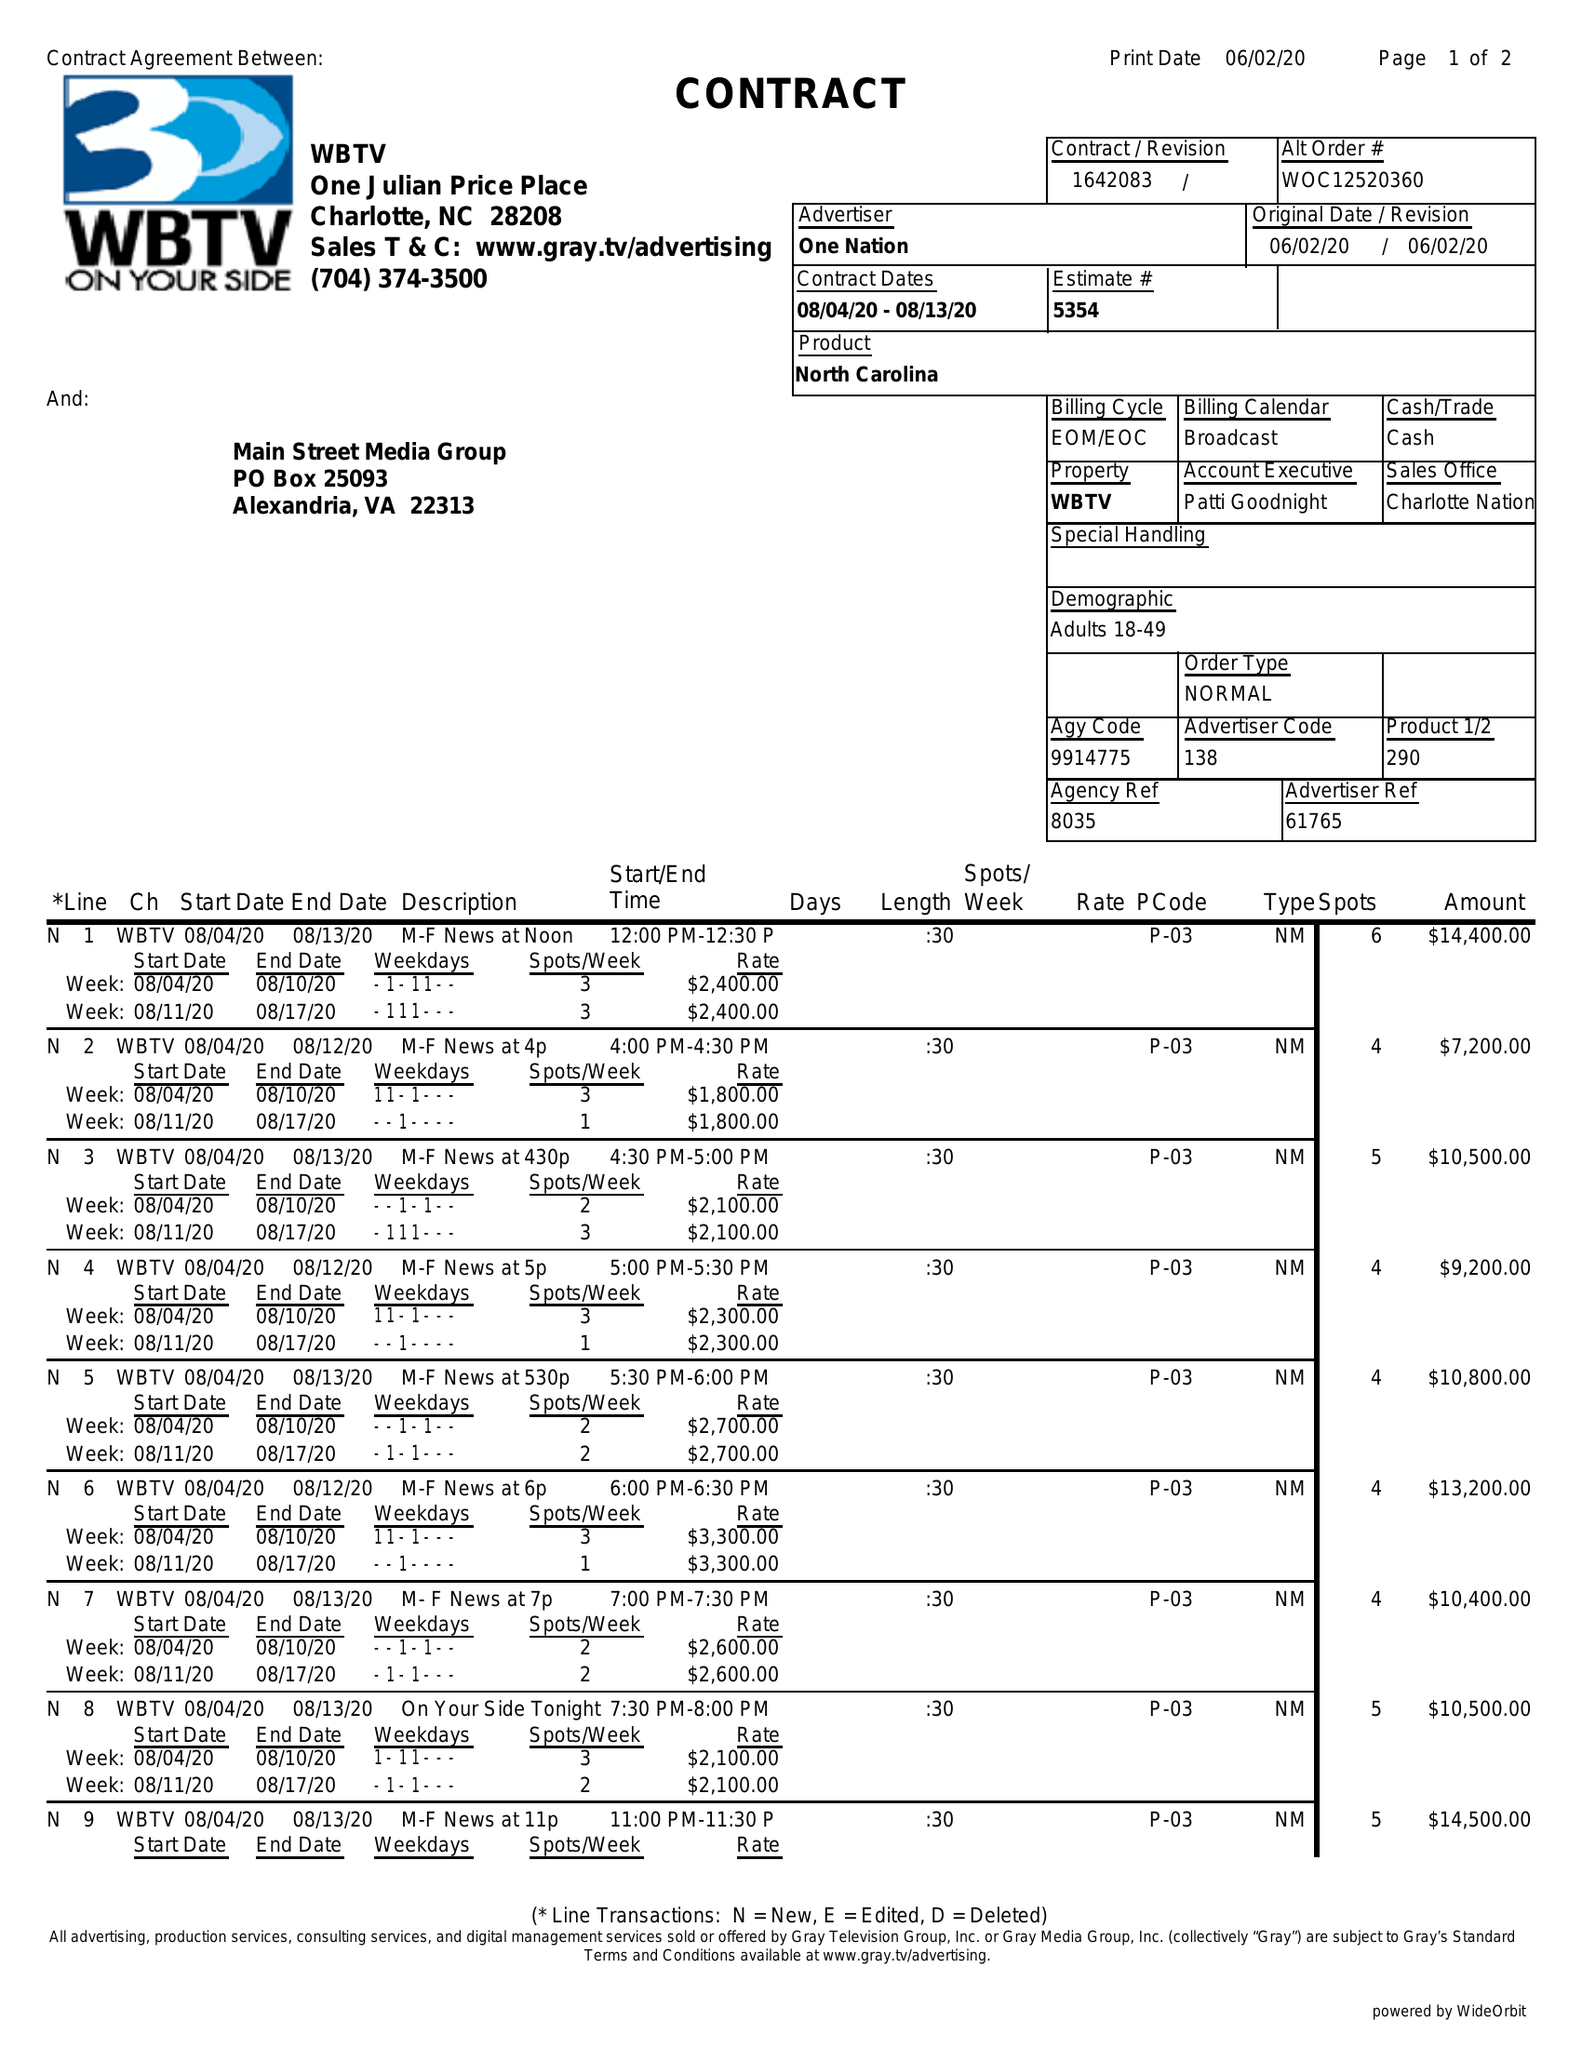What is the value for the gross_amount?
Answer the question using a single word or phrase. 128500.00 